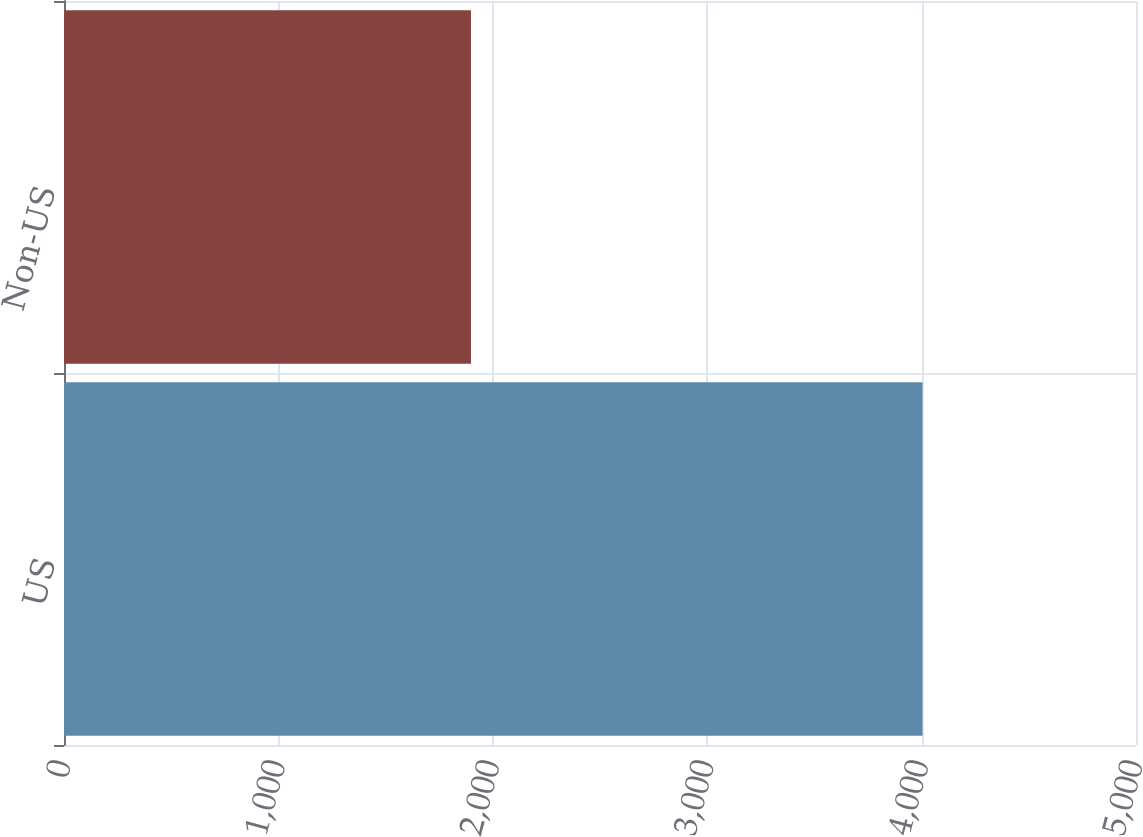Convert chart. <chart><loc_0><loc_0><loc_500><loc_500><bar_chart><fcel>US<fcel>Non-US<nl><fcel>4004.5<fcel>1898.2<nl></chart> 